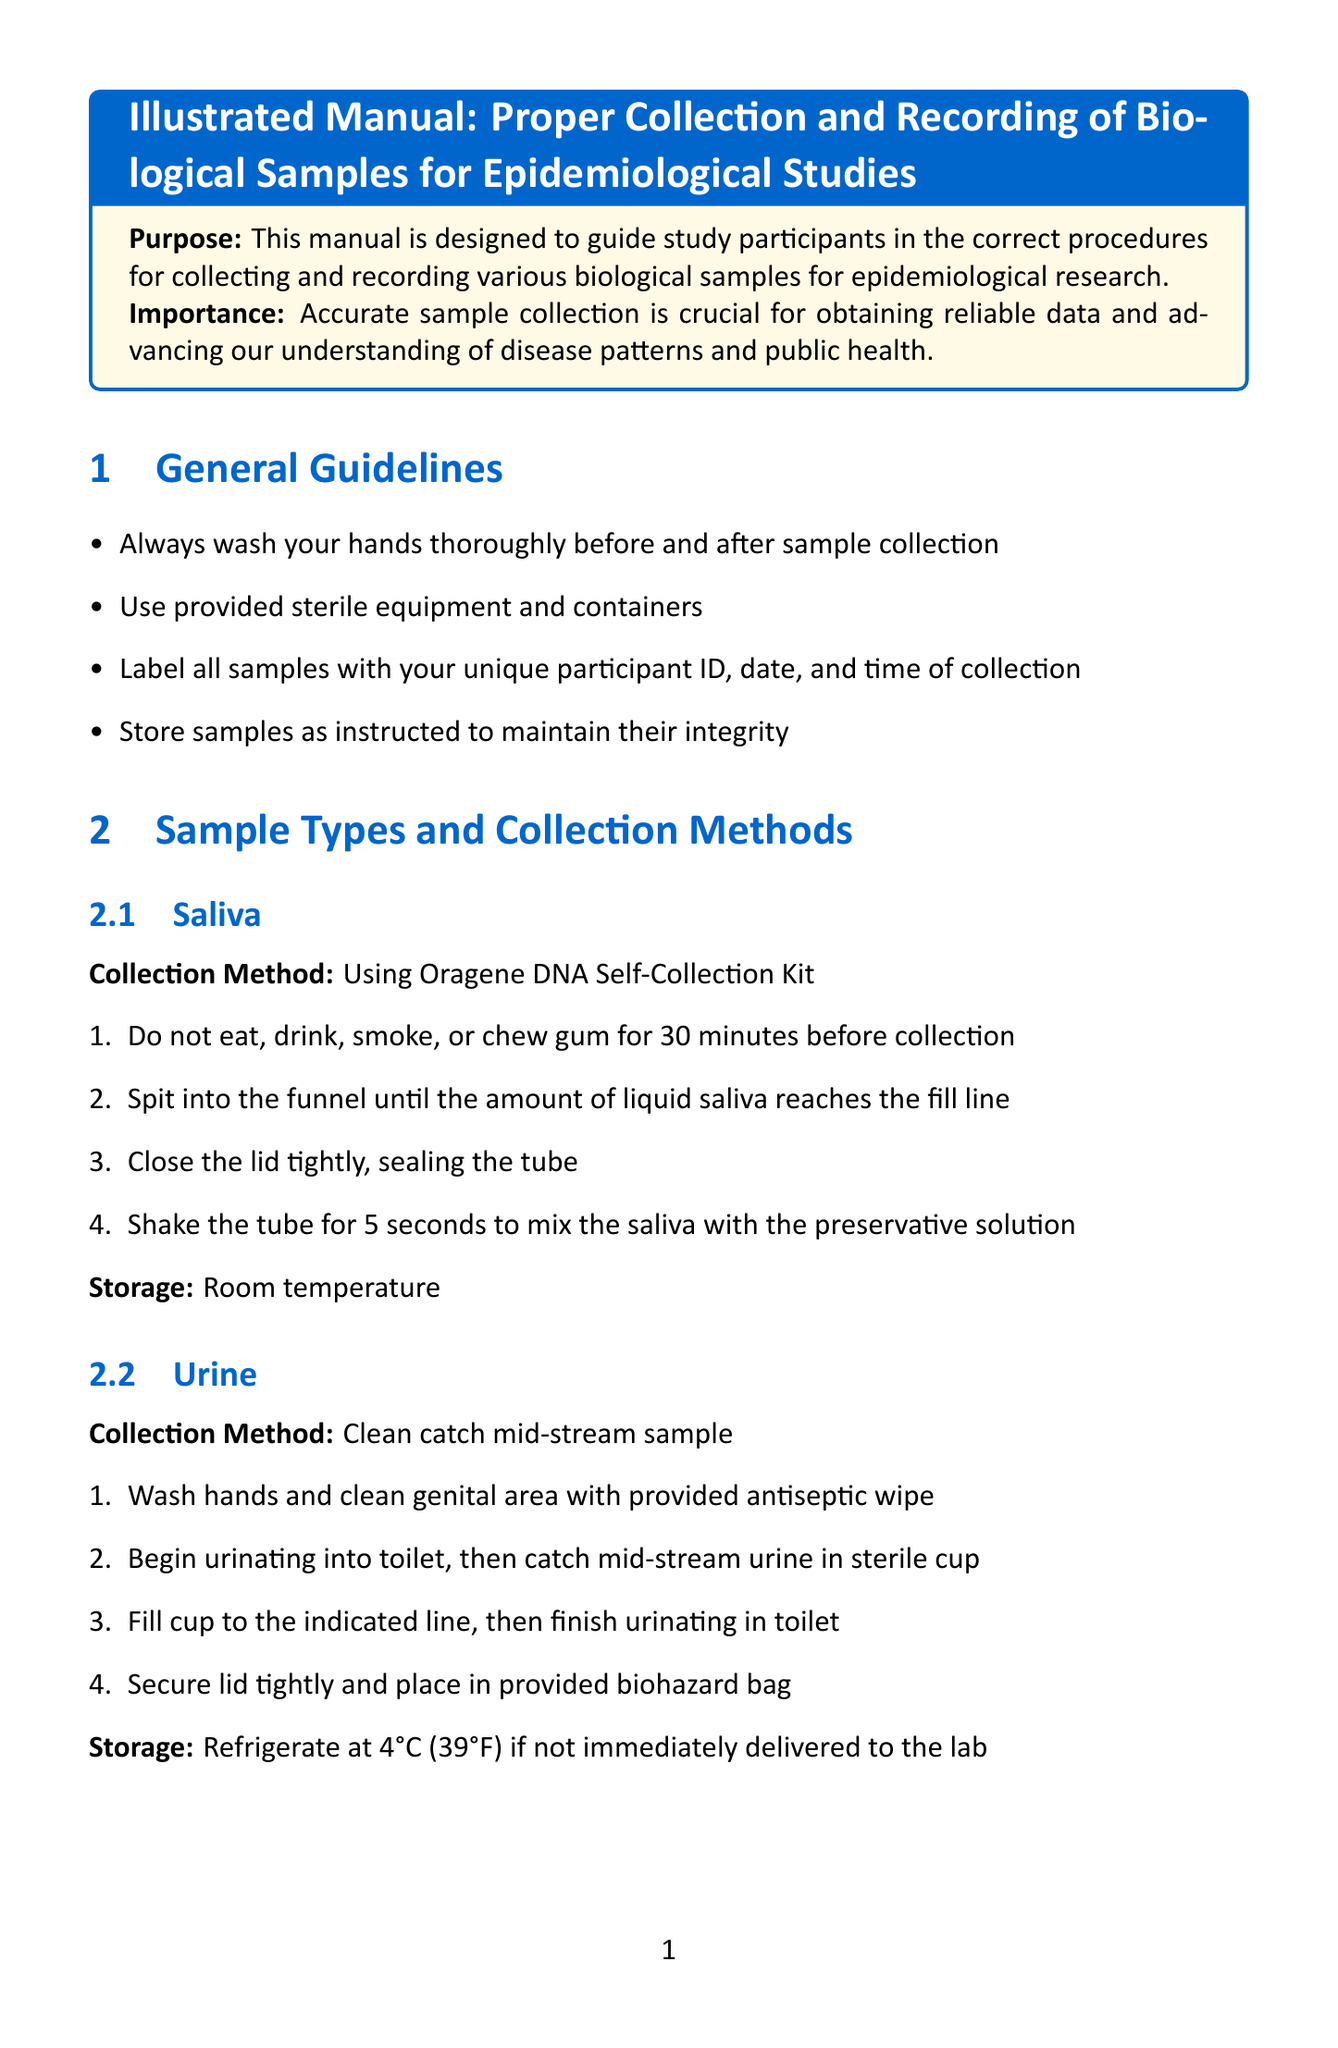What is the purpose of this manual? The manual is designed to guide study participants in the correct procedures for collecting and recording various biological samples for epidemiological research.
Answer: To guide study participants Who is the study coordinator? The contact information section provides the name of the study coordinator.
Answer: Dr. Emily Chen What is the storage condition for saliva samples? The storage condition for saliva samples is mentioned after the collection method.
Answer: Room temperature What should you do after collecting blood? The steps include applying pressure to the puncture site after collection.
Answer: Apply pressure What do you need to do before collecting a nasal swab? The instruction specifies tilting your head back 70 degrees as an initial step.
Answer: Tilt head back 70 degrees What information should be recorded in the paper log? The document specifies that date, time, and type of each sample collected should be noted.
Answer: Date, time, and type What should you do if you miss the collection time? The troubleshooting section outlines the solution for this issue.
Answer: Collect sample as soon as possible What is needed to log in to the electronic diary? The document states that provided credentials are necessary for login.
Answer: Provided credentials 